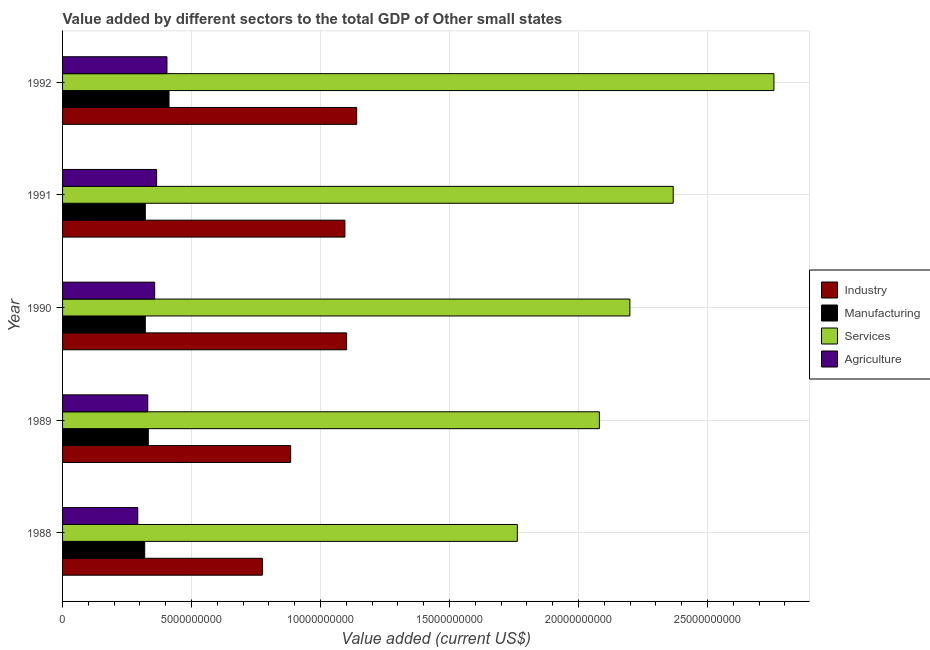How many groups of bars are there?
Make the answer very short. 5. Are the number of bars per tick equal to the number of legend labels?
Provide a short and direct response. Yes. Are the number of bars on each tick of the Y-axis equal?
Ensure brevity in your answer.  Yes. How many bars are there on the 4th tick from the top?
Give a very brief answer. 4. What is the value added by agricultural sector in 1989?
Provide a succinct answer. 3.30e+09. Across all years, what is the maximum value added by agricultural sector?
Your response must be concise. 4.05e+09. Across all years, what is the minimum value added by industrial sector?
Provide a short and direct response. 7.75e+09. In which year was the value added by services sector minimum?
Provide a succinct answer. 1988. What is the total value added by industrial sector in the graph?
Make the answer very short. 4.99e+1. What is the difference between the value added by agricultural sector in 1989 and that in 1992?
Make the answer very short. -7.44e+08. What is the difference between the value added by manufacturing sector in 1992 and the value added by services sector in 1989?
Keep it short and to the point. -1.67e+1. What is the average value added by industrial sector per year?
Offer a very short reply. 9.99e+09. In the year 1990, what is the difference between the value added by industrial sector and value added by services sector?
Keep it short and to the point. -1.10e+1. In how many years, is the value added by agricultural sector greater than 23000000000 US$?
Keep it short and to the point. 0. What is the ratio of the value added by agricultural sector in 1991 to that in 1992?
Your answer should be compact. 0.9. What is the difference between the highest and the second highest value added by services sector?
Give a very brief answer. 3.90e+09. What is the difference between the highest and the lowest value added by industrial sector?
Offer a very short reply. 3.66e+09. In how many years, is the value added by industrial sector greater than the average value added by industrial sector taken over all years?
Keep it short and to the point. 3. Is the sum of the value added by services sector in 1988 and 1992 greater than the maximum value added by industrial sector across all years?
Keep it short and to the point. Yes. What does the 2nd bar from the top in 1992 represents?
Your answer should be compact. Services. What does the 1st bar from the bottom in 1991 represents?
Your answer should be compact. Industry. How many bars are there?
Provide a succinct answer. 20. How many years are there in the graph?
Keep it short and to the point. 5. Does the graph contain grids?
Your response must be concise. Yes. What is the title of the graph?
Provide a short and direct response. Value added by different sectors to the total GDP of Other small states. What is the label or title of the X-axis?
Your response must be concise. Value added (current US$). What is the label or title of the Y-axis?
Offer a very short reply. Year. What is the Value added (current US$) in Industry in 1988?
Ensure brevity in your answer.  7.75e+09. What is the Value added (current US$) in Manufacturing in 1988?
Offer a very short reply. 3.18e+09. What is the Value added (current US$) of Services in 1988?
Offer a terse response. 1.76e+1. What is the Value added (current US$) of Agriculture in 1988?
Keep it short and to the point. 2.92e+09. What is the Value added (current US$) in Industry in 1989?
Offer a terse response. 8.84e+09. What is the Value added (current US$) in Manufacturing in 1989?
Your answer should be compact. 3.32e+09. What is the Value added (current US$) of Services in 1989?
Make the answer very short. 2.08e+1. What is the Value added (current US$) in Agriculture in 1989?
Offer a very short reply. 3.30e+09. What is the Value added (current US$) in Industry in 1990?
Give a very brief answer. 1.10e+1. What is the Value added (current US$) of Manufacturing in 1990?
Ensure brevity in your answer.  3.21e+09. What is the Value added (current US$) of Services in 1990?
Ensure brevity in your answer.  2.20e+1. What is the Value added (current US$) in Agriculture in 1990?
Your answer should be compact. 3.57e+09. What is the Value added (current US$) in Industry in 1991?
Provide a short and direct response. 1.09e+1. What is the Value added (current US$) of Manufacturing in 1991?
Give a very brief answer. 3.21e+09. What is the Value added (current US$) in Services in 1991?
Offer a terse response. 2.37e+1. What is the Value added (current US$) in Agriculture in 1991?
Your answer should be compact. 3.65e+09. What is the Value added (current US$) in Industry in 1992?
Offer a very short reply. 1.14e+1. What is the Value added (current US$) of Manufacturing in 1992?
Ensure brevity in your answer.  4.13e+09. What is the Value added (current US$) of Services in 1992?
Offer a terse response. 2.76e+1. What is the Value added (current US$) of Agriculture in 1992?
Ensure brevity in your answer.  4.05e+09. Across all years, what is the maximum Value added (current US$) in Industry?
Offer a very short reply. 1.14e+1. Across all years, what is the maximum Value added (current US$) in Manufacturing?
Your response must be concise. 4.13e+09. Across all years, what is the maximum Value added (current US$) in Services?
Your response must be concise. 2.76e+1. Across all years, what is the maximum Value added (current US$) of Agriculture?
Make the answer very short. 4.05e+09. Across all years, what is the minimum Value added (current US$) in Industry?
Provide a short and direct response. 7.75e+09. Across all years, what is the minimum Value added (current US$) of Manufacturing?
Give a very brief answer. 3.18e+09. Across all years, what is the minimum Value added (current US$) of Services?
Your answer should be very brief. 1.76e+1. Across all years, what is the minimum Value added (current US$) of Agriculture?
Keep it short and to the point. 2.92e+09. What is the total Value added (current US$) of Industry in the graph?
Give a very brief answer. 4.99e+1. What is the total Value added (current US$) in Manufacturing in the graph?
Provide a short and direct response. 1.71e+1. What is the total Value added (current US$) of Services in the graph?
Your answer should be compact. 1.12e+11. What is the total Value added (current US$) of Agriculture in the graph?
Give a very brief answer. 1.75e+1. What is the difference between the Value added (current US$) of Industry in 1988 and that in 1989?
Give a very brief answer. -1.10e+09. What is the difference between the Value added (current US$) of Manufacturing in 1988 and that in 1989?
Provide a short and direct response. -1.39e+08. What is the difference between the Value added (current US$) in Services in 1988 and that in 1989?
Offer a very short reply. -3.18e+09. What is the difference between the Value added (current US$) of Agriculture in 1988 and that in 1989?
Ensure brevity in your answer.  -3.88e+08. What is the difference between the Value added (current US$) in Industry in 1988 and that in 1990?
Give a very brief answer. -3.26e+09. What is the difference between the Value added (current US$) of Manufacturing in 1988 and that in 1990?
Keep it short and to the point. -2.33e+07. What is the difference between the Value added (current US$) of Services in 1988 and that in 1990?
Provide a succinct answer. -4.36e+09. What is the difference between the Value added (current US$) of Agriculture in 1988 and that in 1990?
Your answer should be very brief. -6.55e+08. What is the difference between the Value added (current US$) in Industry in 1988 and that in 1991?
Make the answer very short. -3.20e+09. What is the difference between the Value added (current US$) in Manufacturing in 1988 and that in 1991?
Offer a terse response. -2.29e+07. What is the difference between the Value added (current US$) in Services in 1988 and that in 1991?
Your response must be concise. -6.04e+09. What is the difference between the Value added (current US$) of Agriculture in 1988 and that in 1991?
Your answer should be compact. -7.32e+08. What is the difference between the Value added (current US$) in Industry in 1988 and that in 1992?
Provide a succinct answer. -3.66e+09. What is the difference between the Value added (current US$) in Manufacturing in 1988 and that in 1992?
Offer a terse response. -9.42e+08. What is the difference between the Value added (current US$) in Services in 1988 and that in 1992?
Offer a terse response. -9.95e+09. What is the difference between the Value added (current US$) in Agriculture in 1988 and that in 1992?
Provide a short and direct response. -1.13e+09. What is the difference between the Value added (current US$) of Industry in 1989 and that in 1990?
Provide a succinct answer. -2.17e+09. What is the difference between the Value added (current US$) of Manufacturing in 1989 and that in 1990?
Keep it short and to the point. 1.16e+08. What is the difference between the Value added (current US$) in Services in 1989 and that in 1990?
Ensure brevity in your answer.  -1.18e+09. What is the difference between the Value added (current US$) in Agriculture in 1989 and that in 1990?
Your answer should be compact. -2.68e+08. What is the difference between the Value added (current US$) in Industry in 1989 and that in 1991?
Your answer should be very brief. -2.10e+09. What is the difference between the Value added (current US$) of Manufacturing in 1989 and that in 1991?
Your answer should be very brief. 1.16e+08. What is the difference between the Value added (current US$) in Services in 1989 and that in 1991?
Your answer should be compact. -2.86e+09. What is the difference between the Value added (current US$) in Agriculture in 1989 and that in 1991?
Make the answer very short. -3.44e+08. What is the difference between the Value added (current US$) in Industry in 1989 and that in 1992?
Provide a succinct answer. -2.56e+09. What is the difference between the Value added (current US$) in Manufacturing in 1989 and that in 1992?
Offer a very short reply. -8.03e+08. What is the difference between the Value added (current US$) in Services in 1989 and that in 1992?
Provide a succinct answer. -6.77e+09. What is the difference between the Value added (current US$) of Agriculture in 1989 and that in 1992?
Offer a terse response. -7.44e+08. What is the difference between the Value added (current US$) in Industry in 1990 and that in 1991?
Offer a terse response. 6.57e+07. What is the difference between the Value added (current US$) in Manufacturing in 1990 and that in 1991?
Your answer should be very brief. 3.41e+05. What is the difference between the Value added (current US$) of Services in 1990 and that in 1991?
Offer a very short reply. -1.68e+09. What is the difference between the Value added (current US$) in Agriculture in 1990 and that in 1991?
Keep it short and to the point. -7.65e+07. What is the difference between the Value added (current US$) in Industry in 1990 and that in 1992?
Provide a succinct answer. -3.91e+08. What is the difference between the Value added (current US$) in Manufacturing in 1990 and that in 1992?
Your answer should be very brief. -9.19e+08. What is the difference between the Value added (current US$) in Services in 1990 and that in 1992?
Offer a terse response. -5.58e+09. What is the difference between the Value added (current US$) in Agriculture in 1990 and that in 1992?
Give a very brief answer. -4.77e+08. What is the difference between the Value added (current US$) of Industry in 1991 and that in 1992?
Offer a terse response. -4.57e+08. What is the difference between the Value added (current US$) of Manufacturing in 1991 and that in 1992?
Your answer should be very brief. -9.19e+08. What is the difference between the Value added (current US$) in Services in 1991 and that in 1992?
Offer a terse response. -3.90e+09. What is the difference between the Value added (current US$) of Agriculture in 1991 and that in 1992?
Keep it short and to the point. -4.00e+08. What is the difference between the Value added (current US$) of Industry in 1988 and the Value added (current US$) of Manufacturing in 1989?
Your answer should be compact. 4.42e+09. What is the difference between the Value added (current US$) in Industry in 1988 and the Value added (current US$) in Services in 1989?
Make the answer very short. -1.31e+1. What is the difference between the Value added (current US$) in Industry in 1988 and the Value added (current US$) in Agriculture in 1989?
Make the answer very short. 4.44e+09. What is the difference between the Value added (current US$) in Manufacturing in 1988 and the Value added (current US$) in Services in 1989?
Make the answer very short. -1.76e+1. What is the difference between the Value added (current US$) in Manufacturing in 1988 and the Value added (current US$) in Agriculture in 1989?
Keep it short and to the point. -1.18e+08. What is the difference between the Value added (current US$) in Services in 1988 and the Value added (current US$) in Agriculture in 1989?
Your answer should be very brief. 1.43e+1. What is the difference between the Value added (current US$) in Industry in 1988 and the Value added (current US$) in Manufacturing in 1990?
Provide a short and direct response. 4.54e+09. What is the difference between the Value added (current US$) in Industry in 1988 and the Value added (current US$) in Services in 1990?
Provide a succinct answer. -1.42e+1. What is the difference between the Value added (current US$) in Industry in 1988 and the Value added (current US$) in Agriculture in 1990?
Offer a terse response. 4.18e+09. What is the difference between the Value added (current US$) in Manufacturing in 1988 and the Value added (current US$) in Services in 1990?
Provide a succinct answer. -1.88e+1. What is the difference between the Value added (current US$) in Manufacturing in 1988 and the Value added (current US$) in Agriculture in 1990?
Give a very brief answer. -3.86e+08. What is the difference between the Value added (current US$) of Services in 1988 and the Value added (current US$) of Agriculture in 1990?
Keep it short and to the point. 1.41e+1. What is the difference between the Value added (current US$) in Industry in 1988 and the Value added (current US$) in Manufacturing in 1991?
Your response must be concise. 4.54e+09. What is the difference between the Value added (current US$) of Industry in 1988 and the Value added (current US$) of Services in 1991?
Provide a short and direct response. -1.59e+1. What is the difference between the Value added (current US$) in Industry in 1988 and the Value added (current US$) in Agriculture in 1991?
Your response must be concise. 4.10e+09. What is the difference between the Value added (current US$) of Manufacturing in 1988 and the Value added (current US$) of Services in 1991?
Your response must be concise. -2.05e+1. What is the difference between the Value added (current US$) in Manufacturing in 1988 and the Value added (current US$) in Agriculture in 1991?
Offer a terse response. -4.62e+08. What is the difference between the Value added (current US$) of Services in 1988 and the Value added (current US$) of Agriculture in 1991?
Ensure brevity in your answer.  1.40e+1. What is the difference between the Value added (current US$) of Industry in 1988 and the Value added (current US$) of Manufacturing in 1992?
Your response must be concise. 3.62e+09. What is the difference between the Value added (current US$) in Industry in 1988 and the Value added (current US$) in Services in 1992?
Keep it short and to the point. -1.98e+1. What is the difference between the Value added (current US$) of Industry in 1988 and the Value added (current US$) of Agriculture in 1992?
Offer a terse response. 3.70e+09. What is the difference between the Value added (current US$) in Manufacturing in 1988 and the Value added (current US$) in Services in 1992?
Your answer should be compact. -2.44e+1. What is the difference between the Value added (current US$) in Manufacturing in 1988 and the Value added (current US$) in Agriculture in 1992?
Your response must be concise. -8.62e+08. What is the difference between the Value added (current US$) of Services in 1988 and the Value added (current US$) of Agriculture in 1992?
Your answer should be very brief. 1.36e+1. What is the difference between the Value added (current US$) of Industry in 1989 and the Value added (current US$) of Manufacturing in 1990?
Make the answer very short. 5.63e+09. What is the difference between the Value added (current US$) in Industry in 1989 and the Value added (current US$) in Services in 1990?
Your response must be concise. -1.32e+1. What is the difference between the Value added (current US$) of Industry in 1989 and the Value added (current US$) of Agriculture in 1990?
Offer a terse response. 5.27e+09. What is the difference between the Value added (current US$) in Manufacturing in 1989 and the Value added (current US$) in Services in 1990?
Keep it short and to the point. -1.87e+1. What is the difference between the Value added (current US$) in Manufacturing in 1989 and the Value added (current US$) in Agriculture in 1990?
Make the answer very short. -2.46e+08. What is the difference between the Value added (current US$) of Services in 1989 and the Value added (current US$) of Agriculture in 1990?
Your response must be concise. 1.72e+1. What is the difference between the Value added (current US$) in Industry in 1989 and the Value added (current US$) in Manufacturing in 1991?
Give a very brief answer. 5.63e+09. What is the difference between the Value added (current US$) in Industry in 1989 and the Value added (current US$) in Services in 1991?
Provide a short and direct response. -1.48e+1. What is the difference between the Value added (current US$) of Industry in 1989 and the Value added (current US$) of Agriculture in 1991?
Your response must be concise. 5.20e+09. What is the difference between the Value added (current US$) of Manufacturing in 1989 and the Value added (current US$) of Services in 1991?
Your answer should be very brief. -2.03e+1. What is the difference between the Value added (current US$) of Manufacturing in 1989 and the Value added (current US$) of Agriculture in 1991?
Keep it short and to the point. -3.23e+08. What is the difference between the Value added (current US$) in Services in 1989 and the Value added (current US$) in Agriculture in 1991?
Your answer should be very brief. 1.72e+1. What is the difference between the Value added (current US$) in Industry in 1989 and the Value added (current US$) in Manufacturing in 1992?
Your response must be concise. 4.72e+09. What is the difference between the Value added (current US$) of Industry in 1989 and the Value added (current US$) of Services in 1992?
Keep it short and to the point. -1.87e+1. What is the difference between the Value added (current US$) in Industry in 1989 and the Value added (current US$) in Agriculture in 1992?
Ensure brevity in your answer.  4.80e+09. What is the difference between the Value added (current US$) in Manufacturing in 1989 and the Value added (current US$) in Services in 1992?
Offer a terse response. -2.43e+1. What is the difference between the Value added (current US$) in Manufacturing in 1989 and the Value added (current US$) in Agriculture in 1992?
Provide a succinct answer. -7.23e+08. What is the difference between the Value added (current US$) of Services in 1989 and the Value added (current US$) of Agriculture in 1992?
Give a very brief answer. 1.68e+1. What is the difference between the Value added (current US$) of Industry in 1990 and the Value added (current US$) of Manufacturing in 1991?
Make the answer very short. 7.80e+09. What is the difference between the Value added (current US$) in Industry in 1990 and the Value added (current US$) in Services in 1991?
Your answer should be compact. -1.27e+1. What is the difference between the Value added (current US$) in Industry in 1990 and the Value added (current US$) in Agriculture in 1991?
Make the answer very short. 7.36e+09. What is the difference between the Value added (current US$) of Manufacturing in 1990 and the Value added (current US$) of Services in 1991?
Provide a short and direct response. -2.05e+1. What is the difference between the Value added (current US$) in Manufacturing in 1990 and the Value added (current US$) in Agriculture in 1991?
Keep it short and to the point. -4.39e+08. What is the difference between the Value added (current US$) of Services in 1990 and the Value added (current US$) of Agriculture in 1991?
Keep it short and to the point. 1.83e+1. What is the difference between the Value added (current US$) in Industry in 1990 and the Value added (current US$) in Manufacturing in 1992?
Your answer should be compact. 6.88e+09. What is the difference between the Value added (current US$) in Industry in 1990 and the Value added (current US$) in Services in 1992?
Make the answer very short. -1.66e+1. What is the difference between the Value added (current US$) of Industry in 1990 and the Value added (current US$) of Agriculture in 1992?
Your answer should be very brief. 6.96e+09. What is the difference between the Value added (current US$) of Manufacturing in 1990 and the Value added (current US$) of Services in 1992?
Keep it short and to the point. -2.44e+1. What is the difference between the Value added (current US$) of Manufacturing in 1990 and the Value added (current US$) of Agriculture in 1992?
Make the answer very short. -8.39e+08. What is the difference between the Value added (current US$) in Services in 1990 and the Value added (current US$) in Agriculture in 1992?
Keep it short and to the point. 1.79e+1. What is the difference between the Value added (current US$) in Industry in 1991 and the Value added (current US$) in Manufacturing in 1992?
Give a very brief answer. 6.82e+09. What is the difference between the Value added (current US$) in Industry in 1991 and the Value added (current US$) in Services in 1992?
Keep it short and to the point. -1.66e+1. What is the difference between the Value added (current US$) of Industry in 1991 and the Value added (current US$) of Agriculture in 1992?
Ensure brevity in your answer.  6.90e+09. What is the difference between the Value added (current US$) in Manufacturing in 1991 and the Value added (current US$) in Services in 1992?
Your response must be concise. -2.44e+1. What is the difference between the Value added (current US$) in Manufacturing in 1991 and the Value added (current US$) in Agriculture in 1992?
Give a very brief answer. -8.39e+08. What is the difference between the Value added (current US$) of Services in 1991 and the Value added (current US$) of Agriculture in 1992?
Your answer should be very brief. 1.96e+1. What is the average Value added (current US$) of Industry per year?
Ensure brevity in your answer.  9.99e+09. What is the average Value added (current US$) of Manufacturing per year?
Make the answer very short. 3.41e+09. What is the average Value added (current US$) of Services per year?
Offer a very short reply. 2.23e+1. What is the average Value added (current US$) of Agriculture per year?
Keep it short and to the point. 3.50e+09. In the year 1988, what is the difference between the Value added (current US$) in Industry and Value added (current US$) in Manufacturing?
Your answer should be compact. 4.56e+09. In the year 1988, what is the difference between the Value added (current US$) of Industry and Value added (current US$) of Services?
Give a very brief answer. -9.88e+09. In the year 1988, what is the difference between the Value added (current US$) of Industry and Value added (current US$) of Agriculture?
Provide a succinct answer. 4.83e+09. In the year 1988, what is the difference between the Value added (current US$) in Manufacturing and Value added (current US$) in Services?
Keep it short and to the point. -1.44e+1. In the year 1988, what is the difference between the Value added (current US$) in Manufacturing and Value added (current US$) in Agriculture?
Provide a succinct answer. 2.69e+08. In the year 1988, what is the difference between the Value added (current US$) of Services and Value added (current US$) of Agriculture?
Make the answer very short. 1.47e+1. In the year 1989, what is the difference between the Value added (current US$) in Industry and Value added (current US$) in Manufacturing?
Your answer should be very brief. 5.52e+09. In the year 1989, what is the difference between the Value added (current US$) in Industry and Value added (current US$) in Services?
Provide a short and direct response. -1.20e+1. In the year 1989, what is the difference between the Value added (current US$) in Industry and Value added (current US$) in Agriculture?
Offer a terse response. 5.54e+09. In the year 1989, what is the difference between the Value added (current US$) of Manufacturing and Value added (current US$) of Services?
Offer a very short reply. -1.75e+1. In the year 1989, what is the difference between the Value added (current US$) of Manufacturing and Value added (current US$) of Agriculture?
Your answer should be very brief. 2.13e+07. In the year 1989, what is the difference between the Value added (current US$) in Services and Value added (current US$) in Agriculture?
Your response must be concise. 1.75e+1. In the year 1990, what is the difference between the Value added (current US$) in Industry and Value added (current US$) in Manufacturing?
Your answer should be very brief. 7.80e+09. In the year 1990, what is the difference between the Value added (current US$) in Industry and Value added (current US$) in Services?
Ensure brevity in your answer.  -1.10e+1. In the year 1990, what is the difference between the Value added (current US$) in Industry and Value added (current US$) in Agriculture?
Offer a very short reply. 7.44e+09. In the year 1990, what is the difference between the Value added (current US$) of Manufacturing and Value added (current US$) of Services?
Ensure brevity in your answer.  -1.88e+1. In the year 1990, what is the difference between the Value added (current US$) in Manufacturing and Value added (current US$) in Agriculture?
Offer a terse response. -3.62e+08. In the year 1990, what is the difference between the Value added (current US$) in Services and Value added (current US$) in Agriculture?
Offer a terse response. 1.84e+1. In the year 1991, what is the difference between the Value added (current US$) of Industry and Value added (current US$) of Manufacturing?
Offer a terse response. 7.74e+09. In the year 1991, what is the difference between the Value added (current US$) of Industry and Value added (current US$) of Services?
Offer a very short reply. -1.27e+1. In the year 1991, what is the difference between the Value added (current US$) in Industry and Value added (current US$) in Agriculture?
Make the answer very short. 7.30e+09. In the year 1991, what is the difference between the Value added (current US$) of Manufacturing and Value added (current US$) of Services?
Your answer should be compact. -2.05e+1. In the year 1991, what is the difference between the Value added (current US$) of Manufacturing and Value added (current US$) of Agriculture?
Provide a succinct answer. -4.39e+08. In the year 1991, what is the difference between the Value added (current US$) of Services and Value added (current US$) of Agriculture?
Your answer should be compact. 2.00e+1. In the year 1992, what is the difference between the Value added (current US$) in Industry and Value added (current US$) in Manufacturing?
Provide a short and direct response. 7.28e+09. In the year 1992, what is the difference between the Value added (current US$) of Industry and Value added (current US$) of Services?
Ensure brevity in your answer.  -1.62e+1. In the year 1992, what is the difference between the Value added (current US$) in Industry and Value added (current US$) in Agriculture?
Ensure brevity in your answer.  7.36e+09. In the year 1992, what is the difference between the Value added (current US$) in Manufacturing and Value added (current US$) in Services?
Offer a very short reply. -2.35e+1. In the year 1992, what is the difference between the Value added (current US$) in Manufacturing and Value added (current US$) in Agriculture?
Your response must be concise. 7.99e+07. In the year 1992, what is the difference between the Value added (current US$) of Services and Value added (current US$) of Agriculture?
Provide a short and direct response. 2.35e+1. What is the ratio of the Value added (current US$) in Industry in 1988 to that in 1989?
Keep it short and to the point. 0.88. What is the ratio of the Value added (current US$) of Manufacturing in 1988 to that in 1989?
Give a very brief answer. 0.96. What is the ratio of the Value added (current US$) in Services in 1988 to that in 1989?
Provide a succinct answer. 0.85. What is the ratio of the Value added (current US$) in Agriculture in 1988 to that in 1989?
Your answer should be compact. 0.88. What is the ratio of the Value added (current US$) of Industry in 1988 to that in 1990?
Offer a very short reply. 0.7. What is the ratio of the Value added (current US$) of Services in 1988 to that in 1990?
Your answer should be very brief. 0.8. What is the ratio of the Value added (current US$) of Agriculture in 1988 to that in 1990?
Your answer should be very brief. 0.82. What is the ratio of the Value added (current US$) in Industry in 1988 to that in 1991?
Provide a succinct answer. 0.71. What is the ratio of the Value added (current US$) of Services in 1988 to that in 1991?
Keep it short and to the point. 0.74. What is the ratio of the Value added (current US$) in Agriculture in 1988 to that in 1991?
Your response must be concise. 0.8. What is the ratio of the Value added (current US$) of Industry in 1988 to that in 1992?
Your answer should be compact. 0.68. What is the ratio of the Value added (current US$) in Manufacturing in 1988 to that in 1992?
Keep it short and to the point. 0.77. What is the ratio of the Value added (current US$) of Services in 1988 to that in 1992?
Your answer should be compact. 0.64. What is the ratio of the Value added (current US$) in Agriculture in 1988 to that in 1992?
Offer a terse response. 0.72. What is the ratio of the Value added (current US$) in Industry in 1989 to that in 1990?
Keep it short and to the point. 0.8. What is the ratio of the Value added (current US$) in Manufacturing in 1989 to that in 1990?
Keep it short and to the point. 1.04. What is the ratio of the Value added (current US$) in Services in 1989 to that in 1990?
Make the answer very short. 0.95. What is the ratio of the Value added (current US$) of Agriculture in 1989 to that in 1990?
Keep it short and to the point. 0.93. What is the ratio of the Value added (current US$) of Industry in 1989 to that in 1991?
Offer a terse response. 0.81. What is the ratio of the Value added (current US$) in Manufacturing in 1989 to that in 1991?
Make the answer very short. 1.04. What is the ratio of the Value added (current US$) in Services in 1989 to that in 1991?
Your response must be concise. 0.88. What is the ratio of the Value added (current US$) of Agriculture in 1989 to that in 1991?
Give a very brief answer. 0.91. What is the ratio of the Value added (current US$) in Industry in 1989 to that in 1992?
Offer a terse response. 0.78. What is the ratio of the Value added (current US$) of Manufacturing in 1989 to that in 1992?
Make the answer very short. 0.81. What is the ratio of the Value added (current US$) in Services in 1989 to that in 1992?
Keep it short and to the point. 0.75. What is the ratio of the Value added (current US$) of Agriculture in 1989 to that in 1992?
Give a very brief answer. 0.82. What is the ratio of the Value added (current US$) in Manufacturing in 1990 to that in 1991?
Offer a very short reply. 1. What is the ratio of the Value added (current US$) of Services in 1990 to that in 1991?
Your response must be concise. 0.93. What is the ratio of the Value added (current US$) of Industry in 1990 to that in 1992?
Ensure brevity in your answer.  0.97. What is the ratio of the Value added (current US$) in Manufacturing in 1990 to that in 1992?
Offer a very short reply. 0.78. What is the ratio of the Value added (current US$) of Services in 1990 to that in 1992?
Make the answer very short. 0.8. What is the ratio of the Value added (current US$) of Agriculture in 1990 to that in 1992?
Provide a short and direct response. 0.88. What is the ratio of the Value added (current US$) in Industry in 1991 to that in 1992?
Give a very brief answer. 0.96. What is the ratio of the Value added (current US$) of Manufacturing in 1991 to that in 1992?
Ensure brevity in your answer.  0.78. What is the ratio of the Value added (current US$) in Services in 1991 to that in 1992?
Keep it short and to the point. 0.86. What is the ratio of the Value added (current US$) of Agriculture in 1991 to that in 1992?
Make the answer very short. 0.9. What is the difference between the highest and the second highest Value added (current US$) of Industry?
Ensure brevity in your answer.  3.91e+08. What is the difference between the highest and the second highest Value added (current US$) of Manufacturing?
Your response must be concise. 8.03e+08. What is the difference between the highest and the second highest Value added (current US$) in Services?
Provide a short and direct response. 3.90e+09. What is the difference between the highest and the second highest Value added (current US$) of Agriculture?
Provide a succinct answer. 4.00e+08. What is the difference between the highest and the lowest Value added (current US$) of Industry?
Keep it short and to the point. 3.66e+09. What is the difference between the highest and the lowest Value added (current US$) of Manufacturing?
Give a very brief answer. 9.42e+08. What is the difference between the highest and the lowest Value added (current US$) of Services?
Your answer should be compact. 9.95e+09. What is the difference between the highest and the lowest Value added (current US$) of Agriculture?
Give a very brief answer. 1.13e+09. 